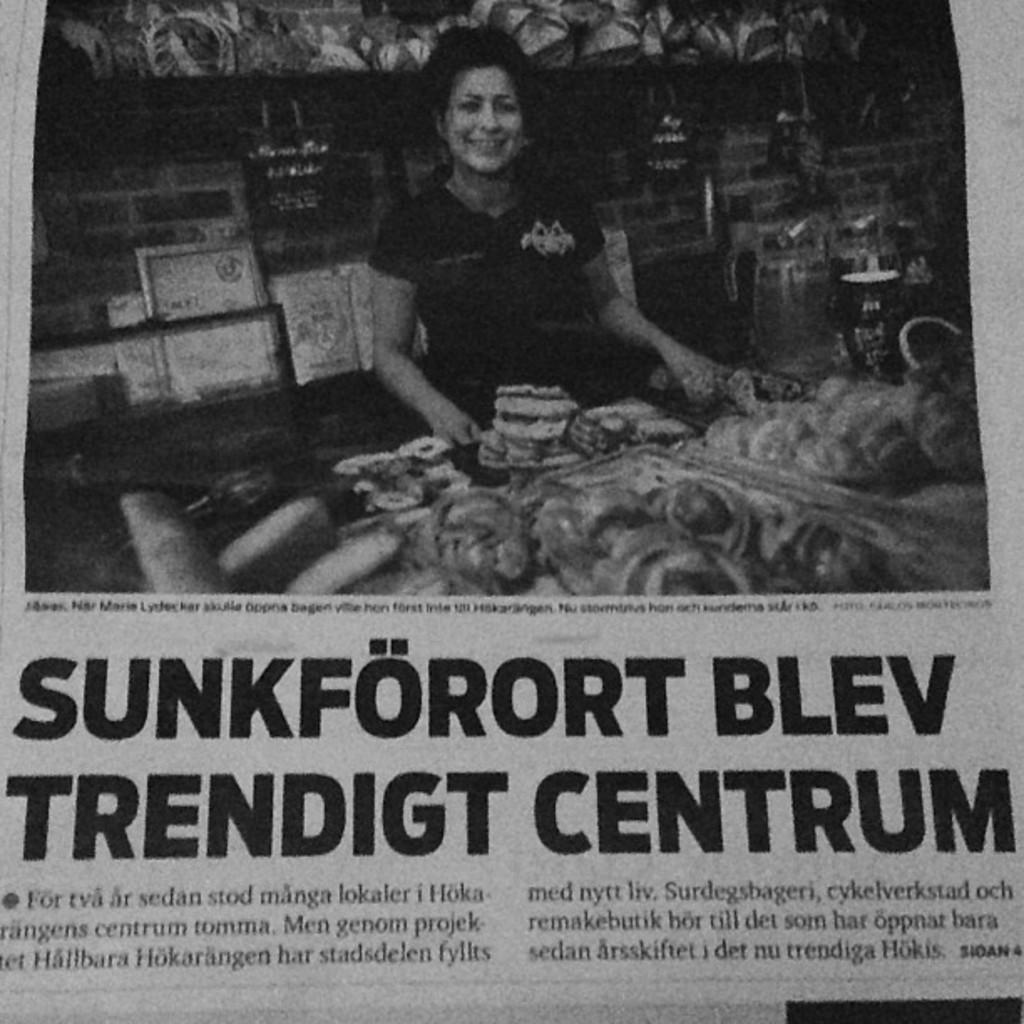<image>
Share a concise interpretation of the image provided. The word Blev is below a picture of a woman with groceries 